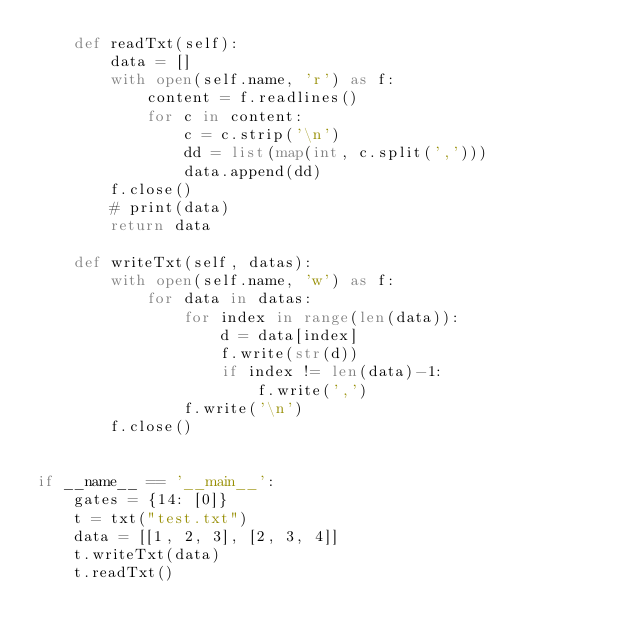Convert code to text. <code><loc_0><loc_0><loc_500><loc_500><_Python_>    def readTxt(self):
        data = []
        with open(self.name, 'r') as f:
            content = f.readlines()
            for c in content:
                c = c.strip('\n')
                dd = list(map(int, c.split(',')))
                data.append(dd)
        f.close()
        # print(data)
        return data

    def writeTxt(self, datas):
        with open(self.name, 'w') as f:
            for data in datas:
                for index in range(len(data)):
                    d = data[index]
                    f.write(str(d))
                    if index != len(data)-1:
                        f.write(',')
                f.write('\n')
        f.close()


if __name__ == '__main__':
    gates = {14: [0]}
    t = txt("test.txt")
    data = [[1, 2, 3], [2, 3, 4]]
    t.writeTxt(data)
    t.readTxt()
</code> 